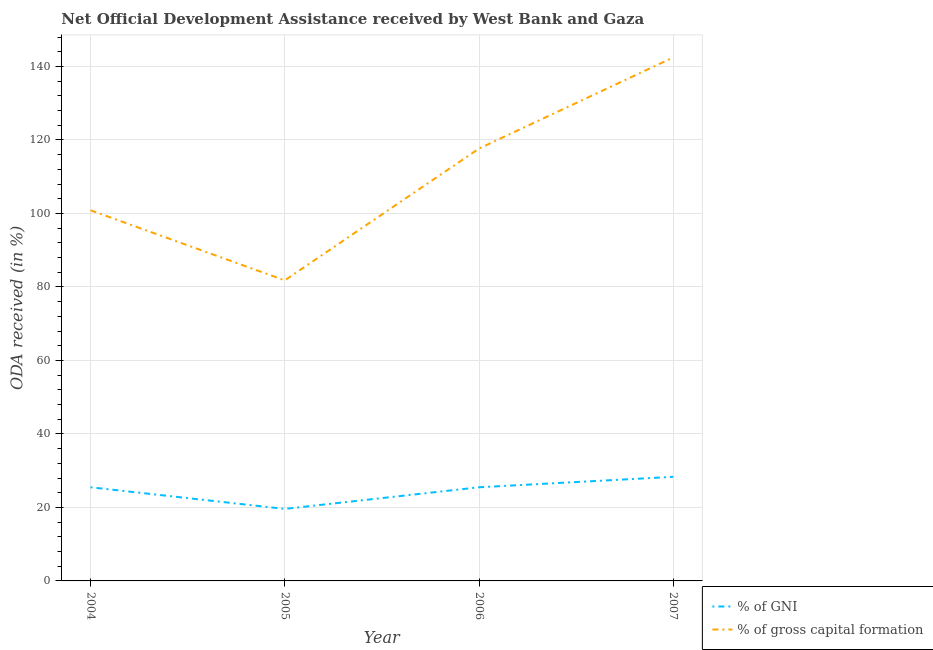Is the number of lines equal to the number of legend labels?
Offer a terse response. Yes. What is the oda received as percentage of gross capital formation in 2005?
Ensure brevity in your answer.  81.78. Across all years, what is the maximum oda received as percentage of gni?
Offer a very short reply. 28.33. Across all years, what is the minimum oda received as percentage of gross capital formation?
Your answer should be compact. 81.78. In which year was the oda received as percentage of gni maximum?
Your answer should be very brief. 2007. What is the total oda received as percentage of gni in the graph?
Provide a short and direct response. 98.89. What is the difference between the oda received as percentage of gross capital formation in 2005 and that in 2006?
Give a very brief answer. -35.87. What is the difference between the oda received as percentage of gni in 2006 and the oda received as percentage of gross capital formation in 2007?
Your answer should be very brief. -116.96. What is the average oda received as percentage of gni per year?
Provide a succinct answer. 24.72. In the year 2004, what is the difference between the oda received as percentage of gross capital formation and oda received as percentage of gni?
Ensure brevity in your answer.  75.37. What is the ratio of the oda received as percentage of gni in 2004 to that in 2005?
Provide a short and direct response. 1.3. Is the oda received as percentage of gross capital formation in 2005 less than that in 2007?
Provide a succinct answer. Yes. What is the difference between the highest and the second highest oda received as percentage of gni?
Keep it short and to the point. 2.85. What is the difference between the highest and the lowest oda received as percentage of gni?
Your response must be concise. 8.73. Is the sum of the oda received as percentage of gni in 2006 and 2007 greater than the maximum oda received as percentage of gross capital formation across all years?
Offer a terse response. No. Is the oda received as percentage of gross capital formation strictly greater than the oda received as percentage of gni over the years?
Offer a terse response. Yes. How many lines are there?
Your response must be concise. 2. How many years are there in the graph?
Give a very brief answer. 4. Does the graph contain any zero values?
Ensure brevity in your answer.  No. Where does the legend appear in the graph?
Give a very brief answer. Bottom right. What is the title of the graph?
Ensure brevity in your answer.  Net Official Development Assistance received by West Bank and Gaza. What is the label or title of the Y-axis?
Provide a short and direct response. ODA received (in %). What is the ODA received (in %) in % of GNI in 2004?
Ensure brevity in your answer.  25.48. What is the ODA received (in %) of % of gross capital formation in 2004?
Provide a succinct answer. 100.86. What is the ODA received (in %) in % of GNI in 2005?
Give a very brief answer. 19.6. What is the ODA received (in %) of % of gross capital formation in 2005?
Provide a succinct answer. 81.78. What is the ODA received (in %) in % of GNI in 2006?
Make the answer very short. 25.48. What is the ODA received (in %) in % of gross capital formation in 2006?
Provide a short and direct response. 117.65. What is the ODA received (in %) in % of GNI in 2007?
Offer a very short reply. 28.33. What is the ODA received (in %) of % of gross capital formation in 2007?
Ensure brevity in your answer.  142.44. Across all years, what is the maximum ODA received (in %) in % of GNI?
Offer a very short reply. 28.33. Across all years, what is the maximum ODA received (in %) in % of gross capital formation?
Your response must be concise. 142.44. Across all years, what is the minimum ODA received (in %) of % of GNI?
Make the answer very short. 19.6. Across all years, what is the minimum ODA received (in %) of % of gross capital formation?
Keep it short and to the point. 81.78. What is the total ODA received (in %) of % of GNI in the graph?
Ensure brevity in your answer.  98.89. What is the total ODA received (in %) in % of gross capital formation in the graph?
Give a very brief answer. 442.73. What is the difference between the ODA received (in %) of % of GNI in 2004 and that in 2005?
Your answer should be compact. 5.89. What is the difference between the ODA received (in %) of % of gross capital formation in 2004 and that in 2005?
Provide a succinct answer. 19.07. What is the difference between the ODA received (in %) of % of GNI in 2004 and that in 2006?
Provide a succinct answer. -0. What is the difference between the ODA received (in %) of % of gross capital formation in 2004 and that in 2006?
Give a very brief answer. -16.79. What is the difference between the ODA received (in %) in % of GNI in 2004 and that in 2007?
Offer a terse response. -2.85. What is the difference between the ODA received (in %) in % of gross capital formation in 2004 and that in 2007?
Give a very brief answer. -41.59. What is the difference between the ODA received (in %) in % of GNI in 2005 and that in 2006?
Make the answer very short. -5.89. What is the difference between the ODA received (in %) of % of gross capital formation in 2005 and that in 2006?
Ensure brevity in your answer.  -35.87. What is the difference between the ODA received (in %) in % of GNI in 2005 and that in 2007?
Provide a short and direct response. -8.73. What is the difference between the ODA received (in %) of % of gross capital formation in 2005 and that in 2007?
Ensure brevity in your answer.  -60.66. What is the difference between the ODA received (in %) in % of GNI in 2006 and that in 2007?
Provide a short and direct response. -2.85. What is the difference between the ODA received (in %) in % of gross capital formation in 2006 and that in 2007?
Your answer should be compact. -24.8. What is the difference between the ODA received (in %) of % of GNI in 2004 and the ODA received (in %) of % of gross capital formation in 2005?
Your response must be concise. -56.3. What is the difference between the ODA received (in %) in % of GNI in 2004 and the ODA received (in %) in % of gross capital formation in 2006?
Your answer should be very brief. -92.17. What is the difference between the ODA received (in %) in % of GNI in 2004 and the ODA received (in %) in % of gross capital formation in 2007?
Make the answer very short. -116.96. What is the difference between the ODA received (in %) in % of GNI in 2005 and the ODA received (in %) in % of gross capital formation in 2006?
Keep it short and to the point. -98.05. What is the difference between the ODA received (in %) of % of GNI in 2005 and the ODA received (in %) of % of gross capital formation in 2007?
Ensure brevity in your answer.  -122.85. What is the difference between the ODA received (in %) of % of GNI in 2006 and the ODA received (in %) of % of gross capital formation in 2007?
Make the answer very short. -116.96. What is the average ODA received (in %) in % of GNI per year?
Your answer should be very brief. 24.72. What is the average ODA received (in %) of % of gross capital formation per year?
Your answer should be compact. 110.68. In the year 2004, what is the difference between the ODA received (in %) of % of GNI and ODA received (in %) of % of gross capital formation?
Ensure brevity in your answer.  -75.37. In the year 2005, what is the difference between the ODA received (in %) of % of GNI and ODA received (in %) of % of gross capital formation?
Give a very brief answer. -62.19. In the year 2006, what is the difference between the ODA received (in %) in % of GNI and ODA received (in %) in % of gross capital formation?
Give a very brief answer. -92.17. In the year 2007, what is the difference between the ODA received (in %) in % of GNI and ODA received (in %) in % of gross capital formation?
Your answer should be very brief. -114.12. What is the ratio of the ODA received (in %) of % of GNI in 2004 to that in 2005?
Give a very brief answer. 1.3. What is the ratio of the ODA received (in %) of % of gross capital formation in 2004 to that in 2005?
Your answer should be compact. 1.23. What is the ratio of the ODA received (in %) of % of gross capital formation in 2004 to that in 2006?
Offer a very short reply. 0.86. What is the ratio of the ODA received (in %) in % of GNI in 2004 to that in 2007?
Your answer should be compact. 0.9. What is the ratio of the ODA received (in %) of % of gross capital formation in 2004 to that in 2007?
Provide a succinct answer. 0.71. What is the ratio of the ODA received (in %) in % of GNI in 2005 to that in 2006?
Offer a terse response. 0.77. What is the ratio of the ODA received (in %) of % of gross capital formation in 2005 to that in 2006?
Keep it short and to the point. 0.7. What is the ratio of the ODA received (in %) of % of GNI in 2005 to that in 2007?
Your response must be concise. 0.69. What is the ratio of the ODA received (in %) in % of gross capital formation in 2005 to that in 2007?
Provide a short and direct response. 0.57. What is the ratio of the ODA received (in %) of % of GNI in 2006 to that in 2007?
Your answer should be compact. 0.9. What is the ratio of the ODA received (in %) of % of gross capital formation in 2006 to that in 2007?
Make the answer very short. 0.83. What is the difference between the highest and the second highest ODA received (in %) of % of GNI?
Ensure brevity in your answer.  2.85. What is the difference between the highest and the second highest ODA received (in %) of % of gross capital formation?
Keep it short and to the point. 24.8. What is the difference between the highest and the lowest ODA received (in %) of % of GNI?
Your response must be concise. 8.73. What is the difference between the highest and the lowest ODA received (in %) in % of gross capital formation?
Keep it short and to the point. 60.66. 